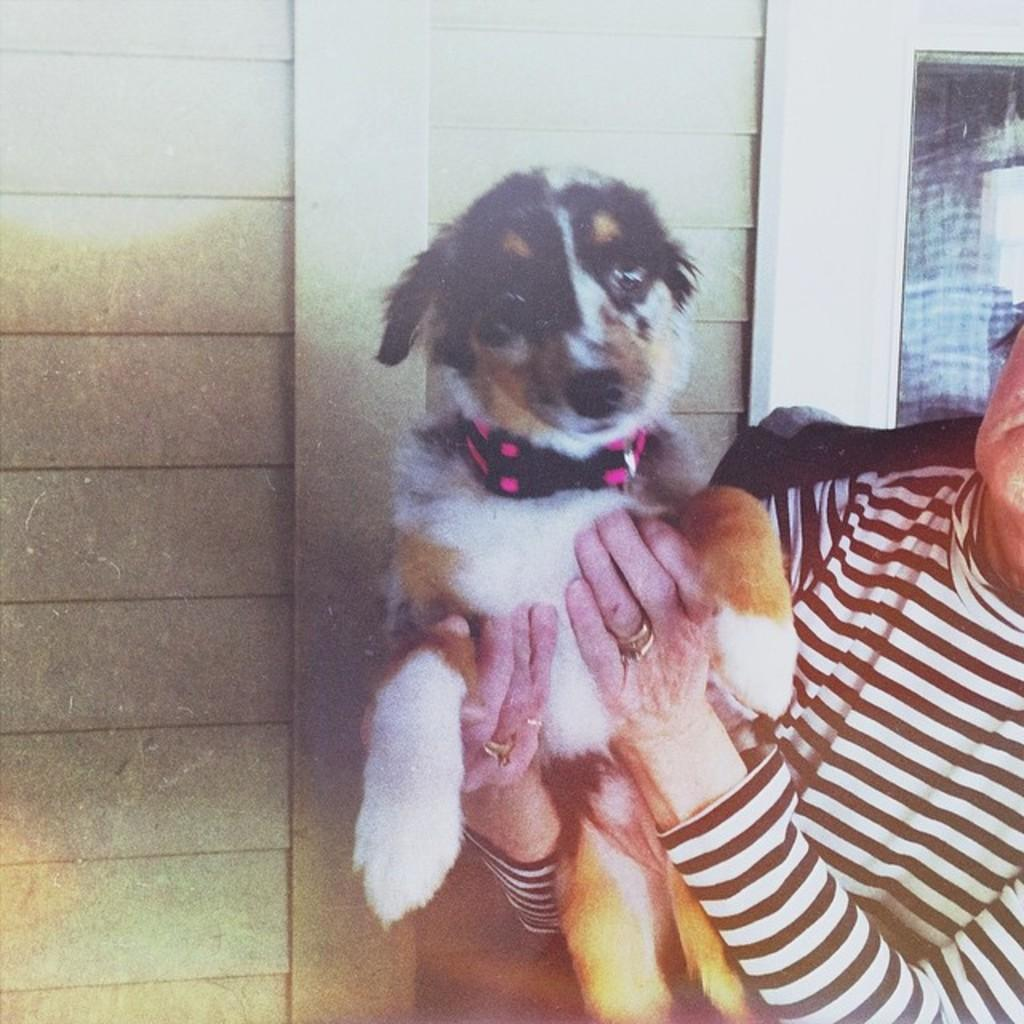What can be seen in the image involving human hands? There are human hands in the image, and they are holding a dog. Can you describe the interaction between the human hands and the dog in the image? The human hands are holding the dog in the image. What historical event is depicted in the image involving the dog and human hands? There is no historical event depicted in the image; it simply shows human hands holding a dog. What type of orange can be seen in the image? There is no orange present in the image. 